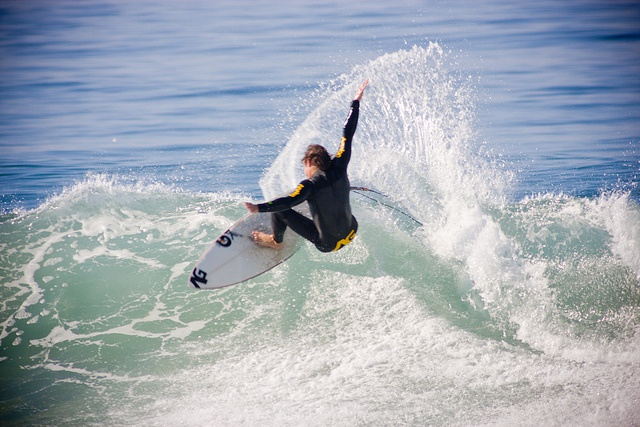Describe the objects in this image and their specific colors. I can see people in navy, black, lightgray, darkgray, and gray tones and surfboard in navy, darkgray, gray, black, and lightgray tones in this image. 